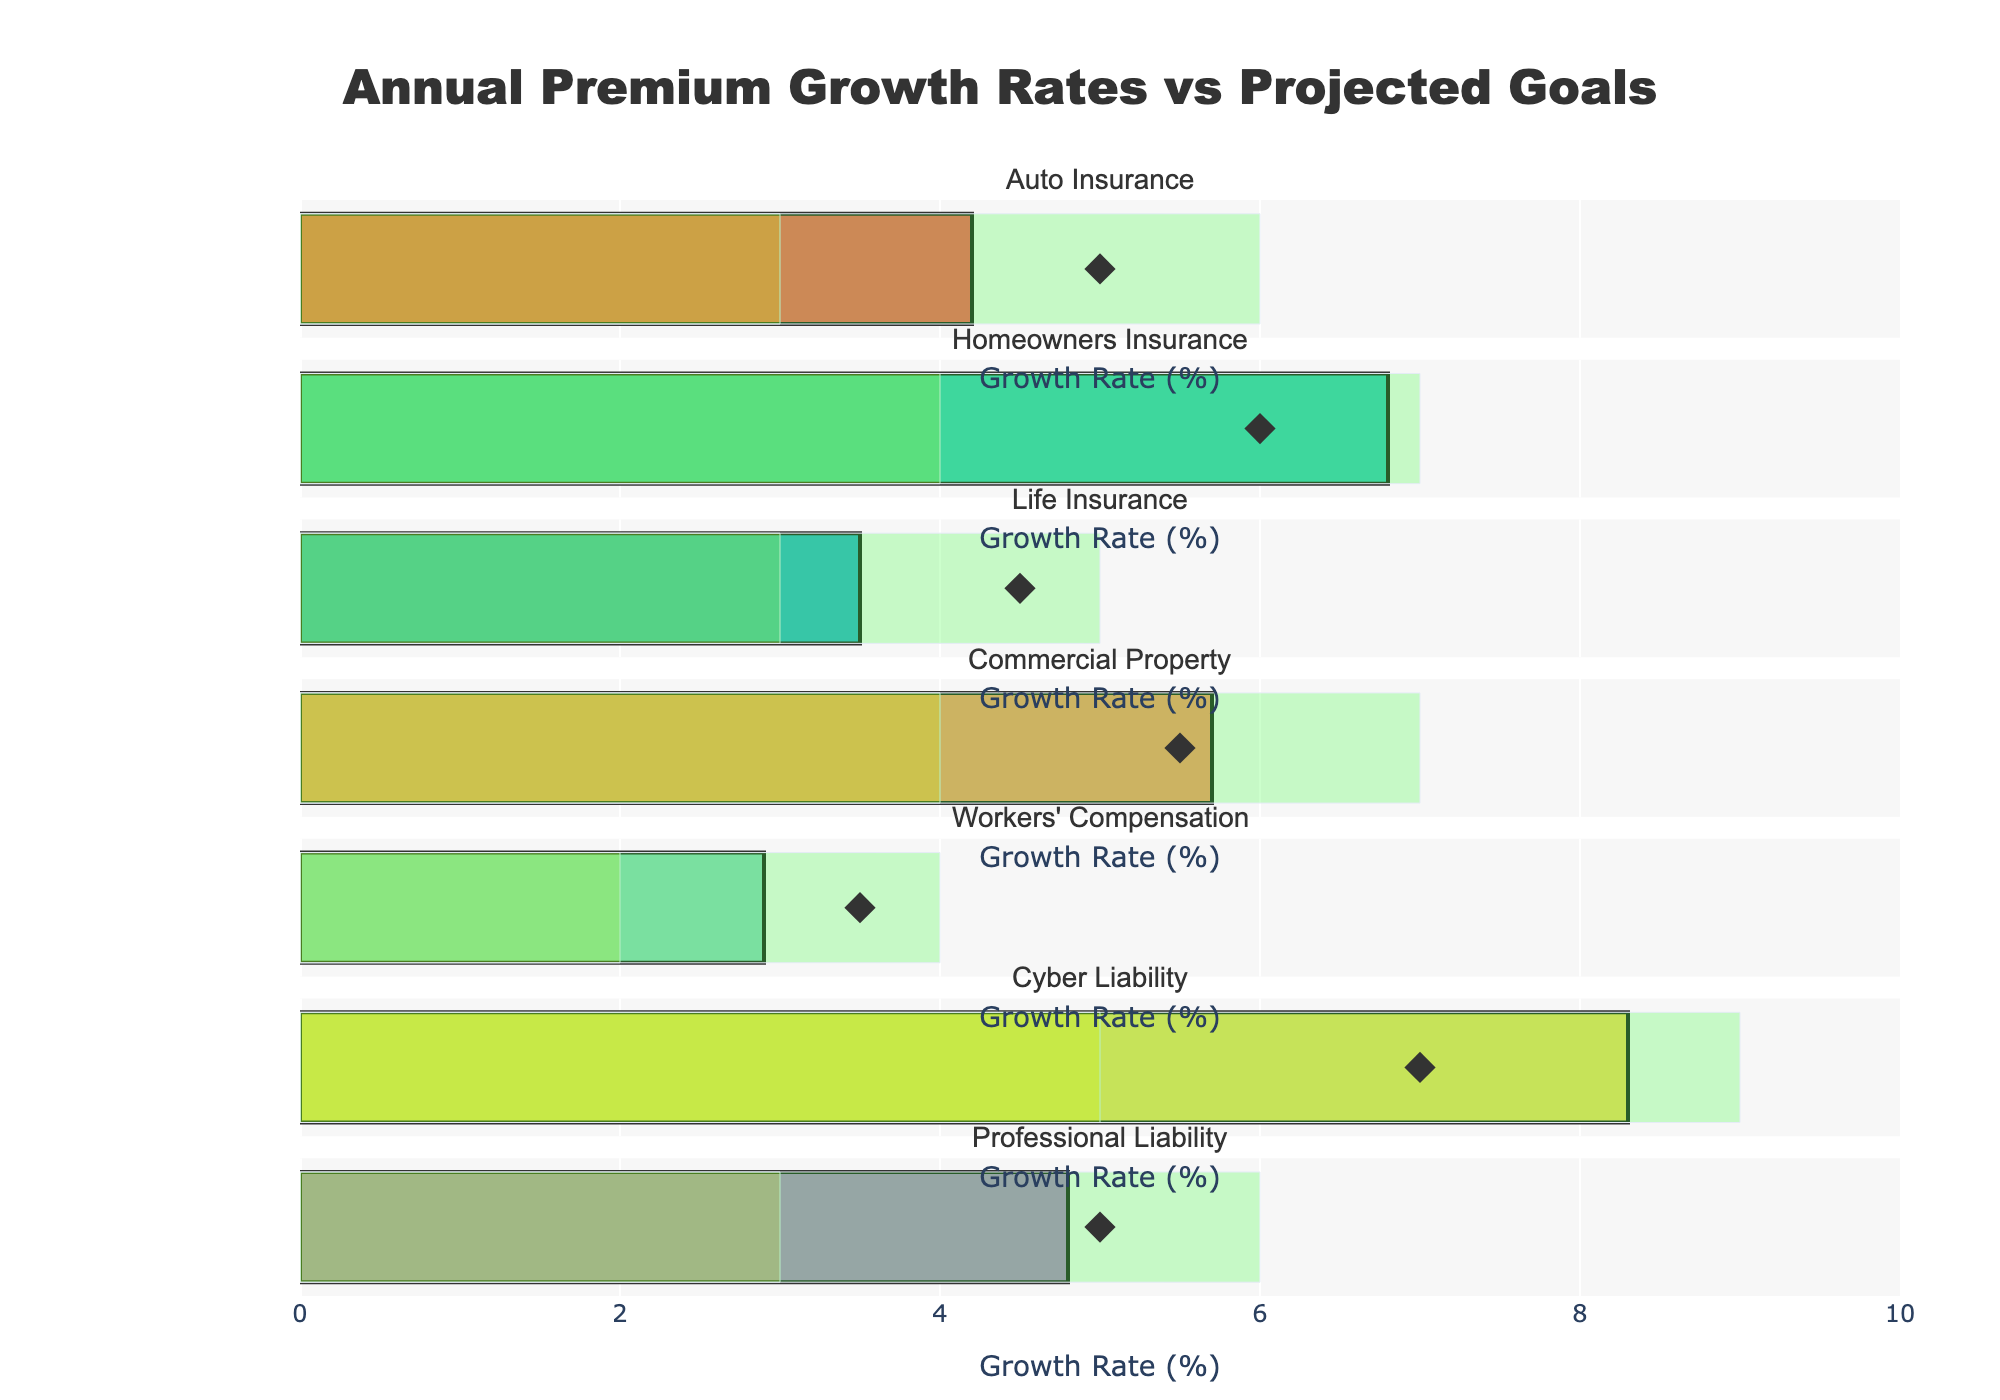What's the title of the chart? The title is located at the top center of the chart, styled in bold.
Answer: Annual Premium Growth Rates vs Projected Goals Which insurance line has the highest actual growth rate? By examining the bars representing the actual growth rates, the tallest bar corresponds to Cyber Liability.
Answer: Cyber Liability What is the target growth rate for Workers' Compensation? Look at the diamond marker corresponding to Workers' Compensation, which indicates their target growth rate.
Answer: 3.5% How does the actual growth rate of Homeowners Insurance compare to its target growth rate? The actual growth rate is represented by the height of the bar, and the target is shown by the diamond marker. Homeowners Insurance has an actual rate higher than its target rate (6.8% vs. 6.0%).
Answer: Higher Which insurance lines have exceeded their target growth rates? Compare the bars with the diamond markers. If a bar extends further than the diamond, it indicates the actual growth rate has exceeded the target. Homeowners Insurance, Commercial Property, and Cyber Liability exceed their targets.
Answer: Homeowners Insurance, Commercial Property, Cyber Liability What is the range of the Excellent Performance band in the plot? Look at the segments marked in green; the Excellent Performance range typically starts from 6 or 7 and goes up to the rightmost edge of the x-axis.
Answer: 6-9% By how much did Auto Insurance miss its target growth rate? Subtract the actual growth rate from the target growth rate for Auto Insurance. Target is 5.0%, actual is 4.2%, so the difference is 0.8%.
Answer: 0.8% Which insurance lines perform below their satisfactory performance levels? Examine if the actual growth rate bars fall within or below the yellow (satisfactory) section. Life Insurance and Workers' Compensation fall under this category.
Answer: Life Insurance, Workers' Compensation What is the combined actual growth rate of Auto Insurance and Life Insurance? Add the actual growth rates of both lines: Auto Insurance (4.2%) and Life Insurance (3.5%). The combined rate is 4.2% + 3.5% = 7.7%.
Answer: 7.7% How many insurance lines are evaluated in the chart? Count the number of subplot titles or bars shown in the figure. There are 7 insurance lines.
Answer: 7 